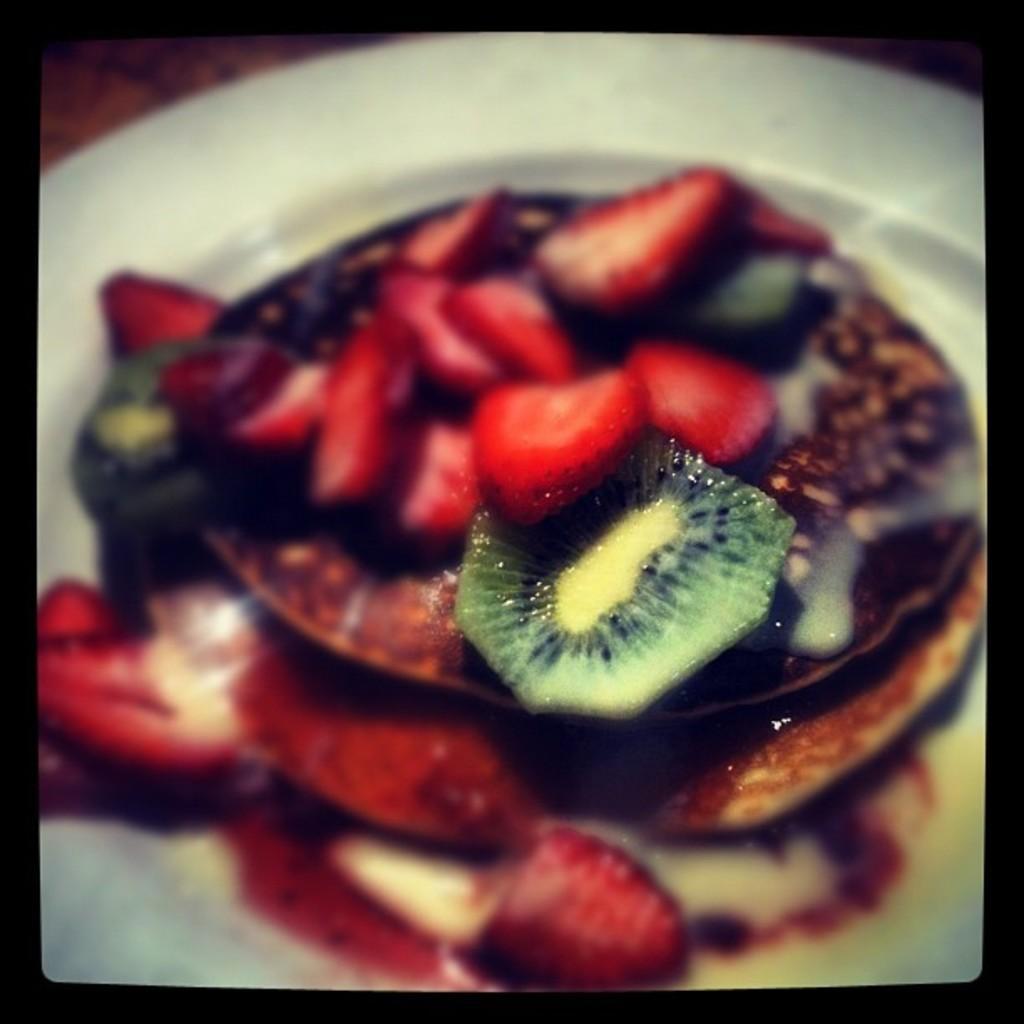Could you give a brief overview of what you see in this image? In this picture we can see a few strawberries and other food items in a plate. 